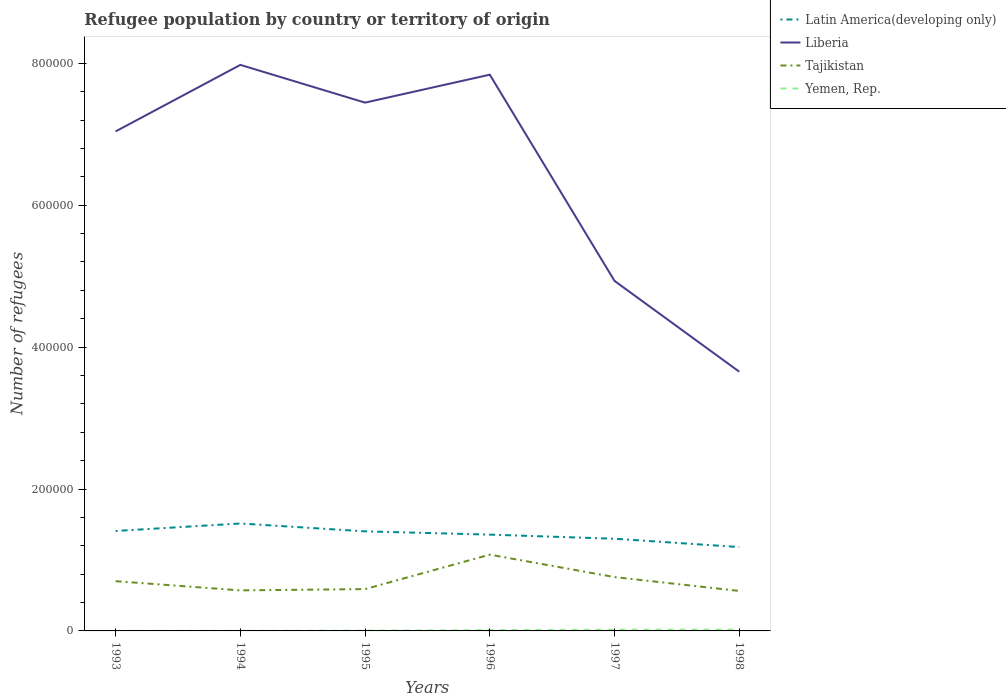How many different coloured lines are there?
Give a very brief answer. 4. Is the number of lines equal to the number of legend labels?
Provide a short and direct response. Yes. Across all years, what is the maximum number of refugees in Tajikistan?
Ensure brevity in your answer.  5.63e+04. In which year was the number of refugees in Latin America(developing only) maximum?
Provide a succinct answer. 1998. What is the total number of refugees in Yemen, Rep. in the graph?
Provide a short and direct response. -214. What is the difference between the highest and the second highest number of refugees in Tajikistan?
Provide a succinct answer. 5.12e+04. What is the difference between the highest and the lowest number of refugees in Latin America(developing only)?
Offer a terse response. 3. Is the number of refugees in Tajikistan strictly greater than the number of refugees in Liberia over the years?
Offer a terse response. Yes. How many lines are there?
Offer a terse response. 4. How many years are there in the graph?
Your answer should be compact. 6. Does the graph contain grids?
Keep it short and to the point. No. Where does the legend appear in the graph?
Offer a terse response. Top right. What is the title of the graph?
Offer a terse response. Refugee population by country or territory of origin. Does "Zambia" appear as one of the legend labels in the graph?
Your response must be concise. No. What is the label or title of the X-axis?
Provide a short and direct response. Years. What is the label or title of the Y-axis?
Your answer should be compact. Number of refugees. What is the Number of refugees in Latin America(developing only) in 1993?
Offer a terse response. 1.41e+05. What is the Number of refugees in Liberia in 1993?
Offer a very short reply. 7.04e+05. What is the Number of refugees of Tajikistan in 1993?
Give a very brief answer. 7.01e+04. What is the Number of refugees of Latin America(developing only) in 1994?
Give a very brief answer. 1.51e+05. What is the Number of refugees of Liberia in 1994?
Offer a very short reply. 7.98e+05. What is the Number of refugees in Tajikistan in 1994?
Keep it short and to the point. 5.71e+04. What is the Number of refugees in Yemen, Rep. in 1994?
Your answer should be compact. 150. What is the Number of refugees of Latin America(developing only) in 1995?
Your answer should be very brief. 1.40e+05. What is the Number of refugees in Liberia in 1995?
Offer a terse response. 7.45e+05. What is the Number of refugees of Tajikistan in 1995?
Your answer should be compact. 5.90e+04. What is the Number of refugees of Yemen, Rep. in 1995?
Keep it short and to the point. 369. What is the Number of refugees of Latin America(developing only) in 1996?
Offer a terse response. 1.36e+05. What is the Number of refugees of Liberia in 1996?
Offer a terse response. 7.84e+05. What is the Number of refugees in Tajikistan in 1996?
Provide a succinct answer. 1.08e+05. What is the Number of refugees of Yemen, Rep. in 1996?
Offer a terse response. 1154. What is the Number of refugees of Latin America(developing only) in 1997?
Offer a terse response. 1.30e+05. What is the Number of refugees in Liberia in 1997?
Offer a terse response. 4.93e+05. What is the Number of refugees in Tajikistan in 1997?
Give a very brief answer. 7.59e+04. What is the Number of refugees in Yemen, Rep. in 1997?
Your answer should be very brief. 1721. What is the Number of refugees in Latin America(developing only) in 1998?
Your response must be concise. 1.18e+05. What is the Number of refugees of Liberia in 1998?
Ensure brevity in your answer.  3.65e+05. What is the Number of refugees of Tajikistan in 1998?
Give a very brief answer. 5.63e+04. What is the Number of refugees in Yemen, Rep. in 1998?
Your response must be concise. 1935. Across all years, what is the maximum Number of refugees of Latin America(developing only)?
Offer a very short reply. 1.51e+05. Across all years, what is the maximum Number of refugees in Liberia?
Offer a very short reply. 7.98e+05. Across all years, what is the maximum Number of refugees of Tajikistan?
Offer a terse response. 1.08e+05. Across all years, what is the maximum Number of refugees in Yemen, Rep.?
Give a very brief answer. 1935. Across all years, what is the minimum Number of refugees of Latin America(developing only)?
Offer a terse response. 1.18e+05. Across all years, what is the minimum Number of refugees in Liberia?
Offer a very short reply. 3.65e+05. Across all years, what is the minimum Number of refugees in Tajikistan?
Provide a succinct answer. 5.63e+04. What is the total Number of refugees in Latin America(developing only) in the graph?
Your answer should be very brief. 8.16e+05. What is the total Number of refugees of Liberia in the graph?
Ensure brevity in your answer.  3.89e+06. What is the total Number of refugees in Tajikistan in the graph?
Provide a succinct answer. 4.26e+05. What is the total Number of refugees of Yemen, Rep. in the graph?
Make the answer very short. 5368. What is the difference between the Number of refugees of Latin America(developing only) in 1993 and that in 1994?
Your answer should be very brief. -1.05e+04. What is the difference between the Number of refugees in Liberia in 1993 and that in 1994?
Provide a succinct answer. -9.38e+04. What is the difference between the Number of refugees of Tajikistan in 1993 and that in 1994?
Your answer should be compact. 1.30e+04. What is the difference between the Number of refugees of Yemen, Rep. in 1993 and that in 1994?
Give a very brief answer. -111. What is the difference between the Number of refugees of Latin America(developing only) in 1993 and that in 1995?
Give a very brief answer. 532. What is the difference between the Number of refugees of Liberia in 1993 and that in 1995?
Give a very brief answer. -4.06e+04. What is the difference between the Number of refugees of Tajikistan in 1993 and that in 1995?
Keep it short and to the point. 1.12e+04. What is the difference between the Number of refugees of Yemen, Rep. in 1993 and that in 1995?
Your answer should be compact. -330. What is the difference between the Number of refugees in Latin America(developing only) in 1993 and that in 1996?
Offer a terse response. 5147. What is the difference between the Number of refugees in Liberia in 1993 and that in 1996?
Keep it short and to the point. -8.00e+04. What is the difference between the Number of refugees in Tajikistan in 1993 and that in 1996?
Offer a terse response. -3.74e+04. What is the difference between the Number of refugees of Yemen, Rep. in 1993 and that in 1996?
Make the answer very short. -1115. What is the difference between the Number of refugees in Latin America(developing only) in 1993 and that in 1997?
Ensure brevity in your answer.  1.09e+04. What is the difference between the Number of refugees in Liberia in 1993 and that in 1997?
Your answer should be compact. 2.11e+05. What is the difference between the Number of refugees in Tajikistan in 1993 and that in 1997?
Make the answer very short. -5770. What is the difference between the Number of refugees in Yemen, Rep. in 1993 and that in 1997?
Ensure brevity in your answer.  -1682. What is the difference between the Number of refugees of Latin America(developing only) in 1993 and that in 1998?
Keep it short and to the point. 2.27e+04. What is the difference between the Number of refugees in Liberia in 1993 and that in 1998?
Make the answer very short. 3.39e+05. What is the difference between the Number of refugees in Tajikistan in 1993 and that in 1998?
Make the answer very short. 1.38e+04. What is the difference between the Number of refugees in Yemen, Rep. in 1993 and that in 1998?
Your answer should be compact. -1896. What is the difference between the Number of refugees in Latin America(developing only) in 1994 and that in 1995?
Your response must be concise. 1.11e+04. What is the difference between the Number of refugees in Liberia in 1994 and that in 1995?
Ensure brevity in your answer.  5.32e+04. What is the difference between the Number of refugees of Tajikistan in 1994 and that in 1995?
Provide a succinct answer. -1812. What is the difference between the Number of refugees of Yemen, Rep. in 1994 and that in 1995?
Ensure brevity in your answer.  -219. What is the difference between the Number of refugees in Latin America(developing only) in 1994 and that in 1996?
Provide a succinct answer. 1.57e+04. What is the difference between the Number of refugees in Liberia in 1994 and that in 1996?
Offer a terse response. 1.38e+04. What is the difference between the Number of refugees in Tajikistan in 1994 and that in 1996?
Provide a succinct answer. -5.04e+04. What is the difference between the Number of refugees in Yemen, Rep. in 1994 and that in 1996?
Your answer should be compact. -1004. What is the difference between the Number of refugees in Latin America(developing only) in 1994 and that in 1997?
Provide a short and direct response. 2.15e+04. What is the difference between the Number of refugees in Liberia in 1994 and that in 1997?
Offer a very short reply. 3.04e+05. What is the difference between the Number of refugees in Tajikistan in 1994 and that in 1997?
Your response must be concise. -1.87e+04. What is the difference between the Number of refugees in Yemen, Rep. in 1994 and that in 1997?
Keep it short and to the point. -1571. What is the difference between the Number of refugees of Latin America(developing only) in 1994 and that in 1998?
Keep it short and to the point. 3.32e+04. What is the difference between the Number of refugees of Liberia in 1994 and that in 1998?
Your response must be concise. 4.32e+05. What is the difference between the Number of refugees of Tajikistan in 1994 and that in 1998?
Ensure brevity in your answer.  795. What is the difference between the Number of refugees in Yemen, Rep. in 1994 and that in 1998?
Provide a short and direct response. -1785. What is the difference between the Number of refugees in Latin America(developing only) in 1995 and that in 1996?
Give a very brief answer. 4615. What is the difference between the Number of refugees of Liberia in 1995 and that in 1996?
Your response must be concise. -3.94e+04. What is the difference between the Number of refugees in Tajikistan in 1995 and that in 1996?
Provide a succinct answer. -4.85e+04. What is the difference between the Number of refugees of Yemen, Rep. in 1995 and that in 1996?
Offer a terse response. -785. What is the difference between the Number of refugees of Latin America(developing only) in 1995 and that in 1997?
Your response must be concise. 1.04e+04. What is the difference between the Number of refugees in Liberia in 1995 and that in 1997?
Keep it short and to the point. 2.51e+05. What is the difference between the Number of refugees in Tajikistan in 1995 and that in 1997?
Your answer should be very brief. -1.69e+04. What is the difference between the Number of refugees of Yemen, Rep. in 1995 and that in 1997?
Keep it short and to the point. -1352. What is the difference between the Number of refugees of Latin America(developing only) in 1995 and that in 1998?
Give a very brief answer. 2.22e+04. What is the difference between the Number of refugees in Liberia in 1995 and that in 1998?
Ensure brevity in your answer.  3.79e+05. What is the difference between the Number of refugees in Tajikistan in 1995 and that in 1998?
Your answer should be very brief. 2607. What is the difference between the Number of refugees of Yemen, Rep. in 1995 and that in 1998?
Ensure brevity in your answer.  -1566. What is the difference between the Number of refugees of Latin America(developing only) in 1996 and that in 1997?
Make the answer very short. 5793. What is the difference between the Number of refugees in Liberia in 1996 and that in 1997?
Offer a terse response. 2.91e+05. What is the difference between the Number of refugees in Tajikistan in 1996 and that in 1997?
Your answer should be very brief. 3.16e+04. What is the difference between the Number of refugees of Yemen, Rep. in 1996 and that in 1997?
Your answer should be very brief. -567. What is the difference between the Number of refugees of Latin America(developing only) in 1996 and that in 1998?
Keep it short and to the point. 1.75e+04. What is the difference between the Number of refugees in Liberia in 1996 and that in 1998?
Your answer should be compact. 4.19e+05. What is the difference between the Number of refugees in Tajikistan in 1996 and that in 1998?
Provide a short and direct response. 5.12e+04. What is the difference between the Number of refugees in Yemen, Rep. in 1996 and that in 1998?
Your response must be concise. -781. What is the difference between the Number of refugees of Latin America(developing only) in 1997 and that in 1998?
Provide a short and direct response. 1.17e+04. What is the difference between the Number of refugees of Liberia in 1997 and that in 1998?
Provide a succinct answer. 1.28e+05. What is the difference between the Number of refugees in Tajikistan in 1997 and that in 1998?
Your answer should be compact. 1.95e+04. What is the difference between the Number of refugees of Yemen, Rep. in 1997 and that in 1998?
Provide a short and direct response. -214. What is the difference between the Number of refugees in Latin America(developing only) in 1993 and the Number of refugees in Liberia in 1994?
Keep it short and to the point. -6.57e+05. What is the difference between the Number of refugees in Latin America(developing only) in 1993 and the Number of refugees in Tajikistan in 1994?
Make the answer very short. 8.37e+04. What is the difference between the Number of refugees of Latin America(developing only) in 1993 and the Number of refugees of Yemen, Rep. in 1994?
Keep it short and to the point. 1.41e+05. What is the difference between the Number of refugees in Liberia in 1993 and the Number of refugees in Tajikistan in 1994?
Ensure brevity in your answer.  6.47e+05. What is the difference between the Number of refugees of Liberia in 1993 and the Number of refugees of Yemen, Rep. in 1994?
Give a very brief answer. 7.04e+05. What is the difference between the Number of refugees of Tajikistan in 1993 and the Number of refugees of Yemen, Rep. in 1994?
Give a very brief answer. 7.00e+04. What is the difference between the Number of refugees in Latin America(developing only) in 1993 and the Number of refugees in Liberia in 1995?
Your response must be concise. -6.04e+05. What is the difference between the Number of refugees of Latin America(developing only) in 1993 and the Number of refugees of Tajikistan in 1995?
Offer a terse response. 8.19e+04. What is the difference between the Number of refugees of Latin America(developing only) in 1993 and the Number of refugees of Yemen, Rep. in 1995?
Make the answer very short. 1.41e+05. What is the difference between the Number of refugees of Liberia in 1993 and the Number of refugees of Tajikistan in 1995?
Offer a terse response. 6.45e+05. What is the difference between the Number of refugees of Liberia in 1993 and the Number of refugees of Yemen, Rep. in 1995?
Give a very brief answer. 7.04e+05. What is the difference between the Number of refugees of Tajikistan in 1993 and the Number of refugees of Yemen, Rep. in 1995?
Your response must be concise. 6.97e+04. What is the difference between the Number of refugees of Latin America(developing only) in 1993 and the Number of refugees of Liberia in 1996?
Give a very brief answer. -6.43e+05. What is the difference between the Number of refugees of Latin America(developing only) in 1993 and the Number of refugees of Tajikistan in 1996?
Offer a very short reply. 3.34e+04. What is the difference between the Number of refugees in Latin America(developing only) in 1993 and the Number of refugees in Yemen, Rep. in 1996?
Keep it short and to the point. 1.40e+05. What is the difference between the Number of refugees in Liberia in 1993 and the Number of refugees in Tajikistan in 1996?
Your answer should be very brief. 5.97e+05. What is the difference between the Number of refugees of Liberia in 1993 and the Number of refugees of Yemen, Rep. in 1996?
Give a very brief answer. 7.03e+05. What is the difference between the Number of refugees of Tajikistan in 1993 and the Number of refugees of Yemen, Rep. in 1996?
Keep it short and to the point. 6.90e+04. What is the difference between the Number of refugees in Latin America(developing only) in 1993 and the Number of refugees in Liberia in 1997?
Keep it short and to the point. -3.52e+05. What is the difference between the Number of refugees of Latin America(developing only) in 1993 and the Number of refugees of Tajikistan in 1997?
Ensure brevity in your answer.  6.50e+04. What is the difference between the Number of refugees of Latin America(developing only) in 1993 and the Number of refugees of Yemen, Rep. in 1997?
Your response must be concise. 1.39e+05. What is the difference between the Number of refugees in Liberia in 1993 and the Number of refugees in Tajikistan in 1997?
Provide a short and direct response. 6.28e+05. What is the difference between the Number of refugees in Liberia in 1993 and the Number of refugees in Yemen, Rep. in 1997?
Your answer should be compact. 7.02e+05. What is the difference between the Number of refugees in Tajikistan in 1993 and the Number of refugees in Yemen, Rep. in 1997?
Make the answer very short. 6.84e+04. What is the difference between the Number of refugees in Latin America(developing only) in 1993 and the Number of refugees in Liberia in 1998?
Your response must be concise. -2.25e+05. What is the difference between the Number of refugees of Latin America(developing only) in 1993 and the Number of refugees of Tajikistan in 1998?
Ensure brevity in your answer.  8.45e+04. What is the difference between the Number of refugees of Latin America(developing only) in 1993 and the Number of refugees of Yemen, Rep. in 1998?
Provide a short and direct response. 1.39e+05. What is the difference between the Number of refugees in Liberia in 1993 and the Number of refugees in Tajikistan in 1998?
Your answer should be compact. 6.48e+05. What is the difference between the Number of refugees in Liberia in 1993 and the Number of refugees in Yemen, Rep. in 1998?
Your response must be concise. 7.02e+05. What is the difference between the Number of refugees of Tajikistan in 1993 and the Number of refugees of Yemen, Rep. in 1998?
Give a very brief answer. 6.82e+04. What is the difference between the Number of refugees in Latin America(developing only) in 1994 and the Number of refugees in Liberia in 1995?
Your answer should be very brief. -5.93e+05. What is the difference between the Number of refugees in Latin America(developing only) in 1994 and the Number of refugees in Tajikistan in 1995?
Ensure brevity in your answer.  9.25e+04. What is the difference between the Number of refugees of Latin America(developing only) in 1994 and the Number of refugees of Yemen, Rep. in 1995?
Give a very brief answer. 1.51e+05. What is the difference between the Number of refugees of Liberia in 1994 and the Number of refugees of Tajikistan in 1995?
Ensure brevity in your answer.  7.39e+05. What is the difference between the Number of refugees in Liberia in 1994 and the Number of refugees in Yemen, Rep. in 1995?
Provide a short and direct response. 7.97e+05. What is the difference between the Number of refugees of Tajikistan in 1994 and the Number of refugees of Yemen, Rep. in 1995?
Provide a short and direct response. 5.68e+04. What is the difference between the Number of refugees in Latin America(developing only) in 1994 and the Number of refugees in Liberia in 1996?
Provide a short and direct response. -6.33e+05. What is the difference between the Number of refugees of Latin America(developing only) in 1994 and the Number of refugees of Tajikistan in 1996?
Ensure brevity in your answer.  4.39e+04. What is the difference between the Number of refugees in Latin America(developing only) in 1994 and the Number of refugees in Yemen, Rep. in 1996?
Give a very brief answer. 1.50e+05. What is the difference between the Number of refugees of Liberia in 1994 and the Number of refugees of Tajikistan in 1996?
Give a very brief answer. 6.90e+05. What is the difference between the Number of refugees of Liberia in 1994 and the Number of refugees of Yemen, Rep. in 1996?
Give a very brief answer. 7.97e+05. What is the difference between the Number of refugees of Tajikistan in 1994 and the Number of refugees of Yemen, Rep. in 1996?
Offer a very short reply. 5.60e+04. What is the difference between the Number of refugees of Latin America(developing only) in 1994 and the Number of refugees of Liberia in 1997?
Give a very brief answer. -3.42e+05. What is the difference between the Number of refugees of Latin America(developing only) in 1994 and the Number of refugees of Tajikistan in 1997?
Give a very brief answer. 7.55e+04. What is the difference between the Number of refugees of Latin America(developing only) in 1994 and the Number of refugees of Yemen, Rep. in 1997?
Ensure brevity in your answer.  1.50e+05. What is the difference between the Number of refugees of Liberia in 1994 and the Number of refugees of Tajikistan in 1997?
Make the answer very short. 7.22e+05. What is the difference between the Number of refugees of Liberia in 1994 and the Number of refugees of Yemen, Rep. in 1997?
Keep it short and to the point. 7.96e+05. What is the difference between the Number of refugees of Tajikistan in 1994 and the Number of refugees of Yemen, Rep. in 1997?
Your answer should be compact. 5.54e+04. What is the difference between the Number of refugees of Latin America(developing only) in 1994 and the Number of refugees of Liberia in 1998?
Offer a very short reply. -2.14e+05. What is the difference between the Number of refugees in Latin America(developing only) in 1994 and the Number of refugees in Tajikistan in 1998?
Offer a very short reply. 9.51e+04. What is the difference between the Number of refugees in Latin America(developing only) in 1994 and the Number of refugees in Yemen, Rep. in 1998?
Provide a short and direct response. 1.49e+05. What is the difference between the Number of refugees of Liberia in 1994 and the Number of refugees of Tajikistan in 1998?
Offer a terse response. 7.41e+05. What is the difference between the Number of refugees of Liberia in 1994 and the Number of refugees of Yemen, Rep. in 1998?
Offer a terse response. 7.96e+05. What is the difference between the Number of refugees of Tajikistan in 1994 and the Number of refugees of Yemen, Rep. in 1998?
Give a very brief answer. 5.52e+04. What is the difference between the Number of refugees of Latin America(developing only) in 1995 and the Number of refugees of Liberia in 1996?
Keep it short and to the point. -6.44e+05. What is the difference between the Number of refugees of Latin America(developing only) in 1995 and the Number of refugees of Tajikistan in 1996?
Offer a very short reply. 3.28e+04. What is the difference between the Number of refugees of Latin America(developing only) in 1995 and the Number of refugees of Yemen, Rep. in 1996?
Your response must be concise. 1.39e+05. What is the difference between the Number of refugees of Liberia in 1995 and the Number of refugees of Tajikistan in 1996?
Keep it short and to the point. 6.37e+05. What is the difference between the Number of refugees of Liberia in 1995 and the Number of refugees of Yemen, Rep. in 1996?
Offer a very short reply. 7.43e+05. What is the difference between the Number of refugees of Tajikistan in 1995 and the Number of refugees of Yemen, Rep. in 1996?
Provide a short and direct response. 5.78e+04. What is the difference between the Number of refugees of Latin America(developing only) in 1995 and the Number of refugees of Liberia in 1997?
Provide a succinct answer. -3.53e+05. What is the difference between the Number of refugees in Latin America(developing only) in 1995 and the Number of refugees in Tajikistan in 1997?
Provide a succinct answer. 6.45e+04. What is the difference between the Number of refugees of Latin America(developing only) in 1995 and the Number of refugees of Yemen, Rep. in 1997?
Ensure brevity in your answer.  1.39e+05. What is the difference between the Number of refugees of Liberia in 1995 and the Number of refugees of Tajikistan in 1997?
Offer a terse response. 6.69e+05. What is the difference between the Number of refugees in Liberia in 1995 and the Number of refugees in Yemen, Rep. in 1997?
Your answer should be compact. 7.43e+05. What is the difference between the Number of refugees in Tajikistan in 1995 and the Number of refugees in Yemen, Rep. in 1997?
Your response must be concise. 5.72e+04. What is the difference between the Number of refugees of Latin America(developing only) in 1995 and the Number of refugees of Liberia in 1998?
Offer a very short reply. -2.25e+05. What is the difference between the Number of refugees in Latin America(developing only) in 1995 and the Number of refugees in Tajikistan in 1998?
Provide a succinct answer. 8.40e+04. What is the difference between the Number of refugees in Latin America(developing only) in 1995 and the Number of refugees in Yemen, Rep. in 1998?
Your answer should be compact. 1.38e+05. What is the difference between the Number of refugees in Liberia in 1995 and the Number of refugees in Tajikistan in 1998?
Make the answer very short. 6.88e+05. What is the difference between the Number of refugees in Liberia in 1995 and the Number of refugees in Yemen, Rep. in 1998?
Your response must be concise. 7.43e+05. What is the difference between the Number of refugees in Tajikistan in 1995 and the Number of refugees in Yemen, Rep. in 1998?
Provide a short and direct response. 5.70e+04. What is the difference between the Number of refugees of Latin America(developing only) in 1996 and the Number of refugees of Liberia in 1997?
Offer a terse response. -3.58e+05. What is the difference between the Number of refugees of Latin America(developing only) in 1996 and the Number of refugees of Tajikistan in 1997?
Provide a succinct answer. 5.98e+04. What is the difference between the Number of refugees of Latin America(developing only) in 1996 and the Number of refugees of Yemen, Rep. in 1997?
Give a very brief answer. 1.34e+05. What is the difference between the Number of refugees of Liberia in 1996 and the Number of refugees of Tajikistan in 1997?
Make the answer very short. 7.08e+05. What is the difference between the Number of refugees in Liberia in 1996 and the Number of refugees in Yemen, Rep. in 1997?
Give a very brief answer. 7.82e+05. What is the difference between the Number of refugees in Tajikistan in 1996 and the Number of refugees in Yemen, Rep. in 1997?
Offer a very short reply. 1.06e+05. What is the difference between the Number of refugees in Latin America(developing only) in 1996 and the Number of refugees in Liberia in 1998?
Offer a terse response. -2.30e+05. What is the difference between the Number of refugees of Latin America(developing only) in 1996 and the Number of refugees of Tajikistan in 1998?
Give a very brief answer. 7.94e+04. What is the difference between the Number of refugees of Latin America(developing only) in 1996 and the Number of refugees of Yemen, Rep. in 1998?
Ensure brevity in your answer.  1.34e+05. What is the difference between the Number of refugees in Liberia in 1996 and the Number of refugees in Tajikistan in 1998?
Your answer should be very brief. 7.28e+05. What is the difference between the Number of refugees in Liberia in 1996 and the Number of refugees in Yemen, Rep. in 1998?
Provide a short and direct response. 7.82e+05. What is the difference between the Number of refugees of Tajikistan in 1996 and the Number of refugees of Yemen, Rep. in 1998?
Make the answer very short. 1.06e+05. What is the difference between the Number of refugees of Latin America(developing only) in 1997 and the Number of refugees of Liberia in 1998?
Keep it short and to the point. -2.35e+05. What is the difference between the Number of refugees in Latin America(developing only) in 1997 and the Number of refugees in Tajikistan in 1998?
Provide a short and direct response. 7.36e+04. What is the difference between the Number of refugees of Latin America(developing only) in 1997 and the Number of refugees of Yemen, Rep. in 1998?
Offer a very short reply. 1.28e+05. What is the difference between the Number of refugees in Liberia in 1997 and the Number of refugees in Tajikistan in 1998?
Keep it short and to the point. 4.37e+05. What is the difference between the Number of refugees of Liberia in 1997 and the Number of refugees of Yemen, Rep. in 1998?
Offer a very short reply. 4.91e+05. What is the difference between the Number of refugees of Tajikistan in 1997 and the Number of refugees of Yemen, Rep. in 1998?
Offer a terse response. 7.39e+04. What is the average Number of refugees in Latin America(developing only) per year?
Offer a very short reply. 1.36e+05. What is the average Number of refugees in Liberia per year?
Offer a terse response. 6.48e+05. What is the average Number of refugees of Tajikistan per year?
Provide a short and direct response. 7.10e+04. What is the average Number of refugees in Yemen, Rep. per year?
Provide a succinct answer. 894.67. In the year 1993, what is the difference between the Number of refugees in Latin America(developing only) and Number of refugees in Liberia?
Ensure brevity in your answer.  -5.63e+05. In the year 1993, what is the difference between the Number of refugees in Latin America(developing only) and Number of refugees in Tajikistan?
Provide a short and direct response. 7.08e+04. In the year 1993, what is the difference between the Number of refugees in Latin America(developing only) and Number of refugees in Yemen, Rep.?
Your answer should be very brief. 1.41e+05. In the year 1993, what is the difference between the Number of refugees in Liberia and Number of refugees in Tajikistan?
Your response must be concise. 6.34e+05. In the year 1993, what is the difference between the Number of refugees in Liberia and Number of refugees in Yemen, Rep.?
Your answer should be compact. 7.04e+05. In the year 1993, what is the difference between the Number of refugees of Tajikistan and Number of refugees of Yemen, Rep.?
Give a very brief answer. 7.01e+04. In the year 1994, what is the difference between the Number of refugees in Latin America(developing only) and Number of refugees in Liberia?
Offer a terse response. -6.46e+05. In the year 1994, what is the difference between the Number of refugees of Latin America(developing only) and Number of refugees of Tajikistan?
Keep it short and to the point. 9.43e+04. In the year 1994, what is the difference between the Number of refugees in Latin America(developing only) and Number of refugees in Yemen, Rep.?
Keep it short and to the point. 1.51e+05. In the year 1994, what is the difference between the Number of refugees in Liberia and Number of refugees in Tajikistan?
Your answer should be very brief. 7.41e+05. In the year 1994, what is the difference between the Number of refugees in Liberia and Number of refugees in Yemen, Rep.?
Offer a very short reply. 7.98e+05. In the year 1994, what is the difference between the Number of refugees of Tajikistan and Number of refugees of Yemen, Rep.?
Keep it short and to the point. 5.70e+04. In the year 1995, what is the difference between the Number of refugees in Latin America(developing only) and Number of refugees in Liberia?
Your answer should be very brief. -6.04e+05. In the year 1995, what is the difference between the Number of refugees of Latin America(developing only) and Number of refugees of Tajikistan?
Provide a succinct answer. 8.14e+04. In the year 1995, what is the difference between the Number of refugees in Latin America(developing only) and Number of refugees in Yemen, Rep.?
Provide a succinct answer. 1.40e+05. In the year 1995, what is the difference between the Number of refugees of Liberia and Number of refugees of Tajikistan?
Your answer should be compact. 6.86e+05. In the year 1995, what is the difference between the Number of refugees in Liberia and Number of refugees in Yemen, Rep.?
Give a very brief answer. 7.44e+05. In the year 1995, what is the difference between the Number of refugees in Tajikistan and Number of refugees in Yemen, Rep.?
Provide a succinct answer. 5.86e+04. In the year 1996, what is the difference between the Number of refugees in Latin America(developing only) and Number of refugees in Liberia?
Your answer should be very brief. -6.48e+05. In the year 1996, what is the difference between the Number of refugees of Latin America(developing only) and Number of refugees of Tajikistan?
Provide a short and direct response. 2.82e+04. In the year 1996, what is the difference between the Number of refugees of Latin America(developing only) and Number of refugees of Yemen, Rep.?
Keep it short and to the point. 1.35e+05. In the year 1996, what is the difference between the Number of refugees of Liberia and Number of refugees of Tajikistan?
Keep it short and to the point. 6.77e+05. In the year 1996, what is the difference between the Number of refugees of Liberia and Number of refugees of Yemen, Rep.?
Your response must be concise. 7.83e+05. In the year 1996, what is the difference between the Number of refugees of Tajikistan and Number of refugees of Yemen, Rep.?
Ensure brevity in your answer.  1.06e+05. In the year 1997, what is the difference between the Number of refugees in Latin America(developing only) and Number of refugees in Liberia?
Your answer should be compact. -3.63e+05. In the year 1997, what is the difference between the Number of refugees in Latin America(developing only) and Number of refugees in Tajikistan?
Give a very brief answer. 5.41e+04. In the year 1997, what is the difference between the Number of refugees of Latin America(developing only) and Number of refugees of Yemen, Rep.?
Provide a short and direct response. 1.28e+05. In the year 1997, what is the difference between the Number of refugees of Liberia and Number of refugees of Tajikistan?
Your answer should be very brief. 4.17e+05. In the year 1997, what is the difference between the Number of refugees in Liberia and Number of refugees in Yemen, Rep.?
Provide a short and direct response. 4.92e+05. In the year 1997, what is the difference between the Number of refugees of Tajikistan and Number of refugees of Yemen, Rep.?
Give a very brief answer. 7.42e+04. In the year 1998, what is the difference between the Number of refugees of Latin America(developing only) and Number of refugees of Liberia?
Your answer should be compact. -2.47e+05. In the year 1998, what is the difference between the Number of refugees of Latin America(developing only) and Number of refugees of Tajikistan?
Your answer should be compact. 6.18e+04. In the year 1998, what is the difference between the Number of refugees of Latin America(developing only) and Number of refugees of Yemen, Rep.?
Ensure brevity in your answer.  1.16e+05. In the year 1998, what is the difference between the Number of refugees in Liberia and Number of refugees in Tajikistan?
Give a very brief answer. 3.09e+05. In the year 1998, what is the difference between the Number of refugees of Liberia and Number of refugees of Yemen, Rep.?
Your response must be concise. 3.63e+05. In the year 1998, what is the difference between the Number of refugees of Tajikistan and Number of refugees of Yemen, Rep.?
Your response must be concise. 5.44e+04. What is the ratio of the Number of refugees in Latin America(developing only) in 1993 to that in 1994?
Give a very brief answer. 0.93. What is the ratio of the Number of refugees in Liberia in 1993 to that in 1994?
Your answer should be very brief. 0.88. What is the ratio of the Number of refugees in Tajikistan in 1993 to that in 1994?
Your answer should be compact. 1.23. What is the ratio of the Number of refugees of Yemen, Rep. in 1993 to that in 1994?
Your answer should be compact. 0.26. What is the ratio of the Number of refugees of Liberia in 1993 to that in 1995?
Keep it short and to the point. 0.95. What is the ratio of the Number of refugees of Tajikistan in 1993 to that in 1995?
Offer a very short reply. 1.19. What is the ratio of the Number of refugees of Yemen, Rep. in 1993 to that in 1995?
Give a very brief answer. 0.11. What is the ratio of the Number of refugees of Latin America(developing only) in 1993 to that in 1996?
Provide a succinct answer. 1.04. What is the ratio of the Number of refugees of Liberia in 1993 to that in 1996?
Give a very brief answer. 0.9. What is the ratio of the Number of refugees in Tajikistan in 1993 to that in 1996?
Your response must be concise. 0.65. What is the ratio of the Number of refugees in Yemen, Rep. in 1993 to that in 1996?
Provide a succinct answer. 0.03. What is the ratio of the Number of refugees of Latin America(developing only) in 1993 to that in 1997?
Provide a succinct answer. 1.08. What is the ratio of the Number of refugees in Liberia in 1993 to that in 1997?
Offer a terse response. 1.43. What is the ratio of the Number of refugees of Tajikistan in 1993 to that in 1997?
Make the answer very short. 0.92. What is the ratio of the Number of refugees in Yemen, Rep. in 1993 to that in 1997?
Your answer should be compact. 0.02. What is the ratio of the Number of refugees in Latin America(developing only) in 1993 to that in 1998?
Offer a very short reply. 1.19. What is the ratio of the Number of refugees in Liberia in 1993 to that in 1998?
Give a very brief answer. 1.93. What is the ratio of the Number of refugees of Tajikistan in 1993 to that in 1998?
Keep it short and to the point. 1.24. What is the ratio of the Number of refugees of Yemen, Rep. in 1993 to that in 1998?
Give a very brief answer. 0.02. What is the ratio of the Number of refugees in Latin America(developing only) in 1994 to that in 1995?
Provide a short and direct response. 1.08. What is the ratio of the Number of refugees of Liberia in 1994 to that in 1995?
Offer a terse response. 1.07. What is the ratio of the Number of refugees in Tajikistan in 1994 to that in 1995?
Give a very brief answer. 0.97. What is the ratio of the Number of refugees of Yemen, Rep. in 1994 to that in 1995?
Your response must be concise. 0.41. What is the ratio of the Number of refugees of Latin America(developing only) in 1994 to that in 1996?
Your response must be concise. 1.12. What is the ratio of the Number of refugees in Liberia in 1994 to that in 1996?
Keep it short and to the point. 1.02. What is the ratio of the Number of refugees of Tajikistan in 1994 to that in 1996?
Provide a short and direct response. 0.53. What is the ratio of the Number of refugees of Yemen, Rep. in 1994 to that in 1996?
Make the answer very short. 0.13. What is the ratio of the Number of refugees of Latin America(developing only) in 1994 to that in 1997?
Your response must be concise. 1.17. What is the ratio of the Number of refugees of Liberia in 1994 to that in 1997?
Offer a terse response. 1.62. What is the ratio of the Number of refugees in Tajikistan in 1994 to that in 1997?
Your answer should be compact. 0.75. What is the ratio of the Number of refugees in Yemen, Rep. in 1994 to that in 1997?
Provide a succinct answer. 0.09. What is the ratio of the Number of refugees in Latin America(developing only) in 1994 to that in 1998?
Make the answer very short. 1.28. What is the ratio of the Number of refugees in Liberia in 1994 to that in 1998?
Give a very brief answer. 2.18. What is the ratio of the Number of refugees of Tajikistan in 1994 to that in 1998?
Provide a succinct answer. 1.01. What is the ratio of the Number of refugees in Yemen, Rep. in 1994 to that in 1998?
Keep it short and to the point. 0.08. What is the ratio of the Number of refugees of Latin America(developing only) in 1995 to that in 1996?
Provide a short and direct response. 1.03. What is the ratio of the Number of refugees of Liberia in 1995 to that in 1996?
Keep it short and to the point. 0.95. What is the ratio of the Number of refugees of Tajikistan in 1995 to that in 1996?
Give a very brief answer. 0.55. What is the ratio of the Number of refugees of Yemen, Rep. in 1995 to that in 1996?
Provide a short and direct response. 0.32. What is the ratio of the Number of refugees in Latin America(developing only) in 1995 to that in 1997?
Your response must be concise. 1.08. What is the ratio of the Number of refugees in Liberia in 1995 to that in 1997?
Ensure brevity in your answer.  1.51. What is the ratio of the Number of refugees in Tajikistan in 1995 to that in 1997?
Make the answer very short. 0.78. What is the ratio of the Number of refugees of Yemen, Rep. in 1995 to that in 1997?
Ensure brevity in your answer.  0.21. What is the ratio of the Number of refugees in Latin America(developing only) in 1995 to that in 1998?
Your response must be concise. 1.19. What is the ratio of the Number of refugees of Liberia in 1995 to that in 1998?
Your answer should be compact. 2.04. What is the ratio of the Number of refugees of Tajikistan in 1995 to that in 1998?
Your answer should be very brief. 1.05. What is the ratio of the Number of refugees in Yemen, Rep. in 1995 to that in 1998?
Offer a terse response. 0.19. What is the ratio of the Number of refugees of Latin America(developing only) in 1996 to that in 1997?
Your answer should be very brief. 1.04. What is the ratio of the Number of refugees of Liberia in 1996 to that in 1997?
Your response must be concise. 1.59. What is the ratio of the Number of refugees of Tajikistan in 1996 to that in 1997?
Provide a short and direct response. 1.42. What is the ratio of the Number of refugees in Yemen, Rep. in 1996 to that in 1997?
Provide a succinct answer. 0.67. What is the ratio of the Number of refugees of Latin America(developing only) in 1996 to that in 1998?
Your answer should be very brief. 1.15. What is the ratio of the Number of refugees of Liberia in 1996 to that in 1998?
Your answer should be very brief. 2.15. What is the ratio of the Number of refugees of Tajikistan in 1996 to that in 1998?
Offer a terse response. 1.91. What is the ratio of the Number of refugees in Yemen, Rep. in 1996 to that in 1998?
Your answer should be compact. 0.6. What is the ratio of the Number of refugees in Latin America(developing only) in 1997 to that in 1998?
Offer a very short reply. 1.1. What is the ratio of the Number of refugees of Liberia in 1997 to that in 1998?
Give a very brief answer. 1.35. What is the ratio of the Number of refugees of Tajikistan in 1997 to that in 1998?
Offer a terse response. 1.35. What is the ratio of the Number of refugees of Yemen, Rep. in 1997 to that in 1998?
Offer a terse response. 0.89. What is the difference between the highest and the second highest Number of refugees of Latin America(developing only)?
Your response must be concise. 1.05e+04. What is the difference between the highest and the second highest Number of refugees of Liberia?
Provide a short and direct response. 1.38e+04. What is the difference between the highest and the second highest Number of refugees in Tajikistan?
Give a very brief answer. 3.16e+04. What is the difference between the highest and the second highest Number of refugees of Yemen, Rep.?
Give a very brief answer. 214. What is the difference between the highest and the lowest Number of refugees of Latin America(developing only)?
Your response must be concise. 3.32e+04. What is the difference between the highest and the lowest Number of refugees in Liberia?
Offer a terse response. 4.32e+05. What is the difference between the highest and the lowest Number of refugees in Tajikistan?
Your response must be concise. 5.12e+04. What is the difference between the highest and the lowest Number of refugees of Yemen, Rep.?
Your response must be concise. 1896. 